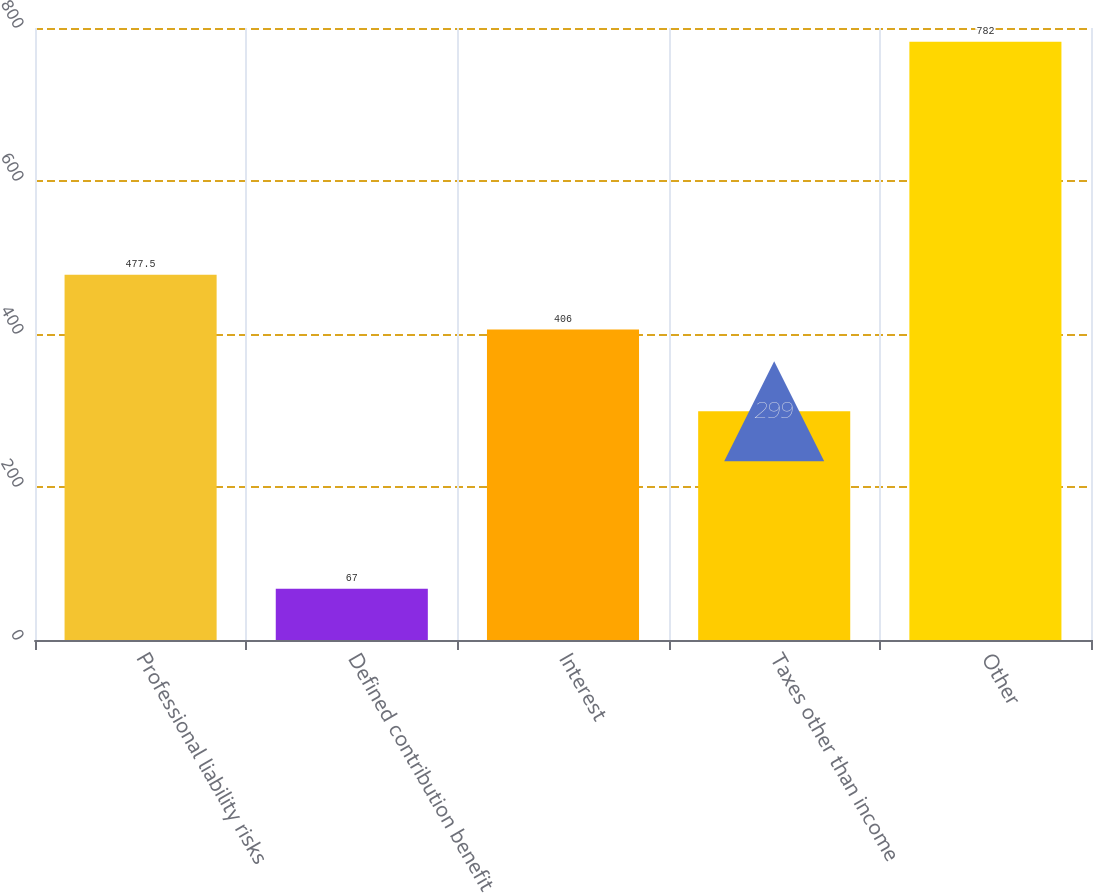Convert chart. <chart><loc_0><loc_0><loc_500><loc_500><bar_chart><fcel>Professional liability risks<fcel>Defined contribution benefit<fcel>Interest<fcel>Taxes other than income<fcel>Other<nl><fcel>477.5<fcel>67<fcel>406<fcel>299<fcel>782<nl></chart> 